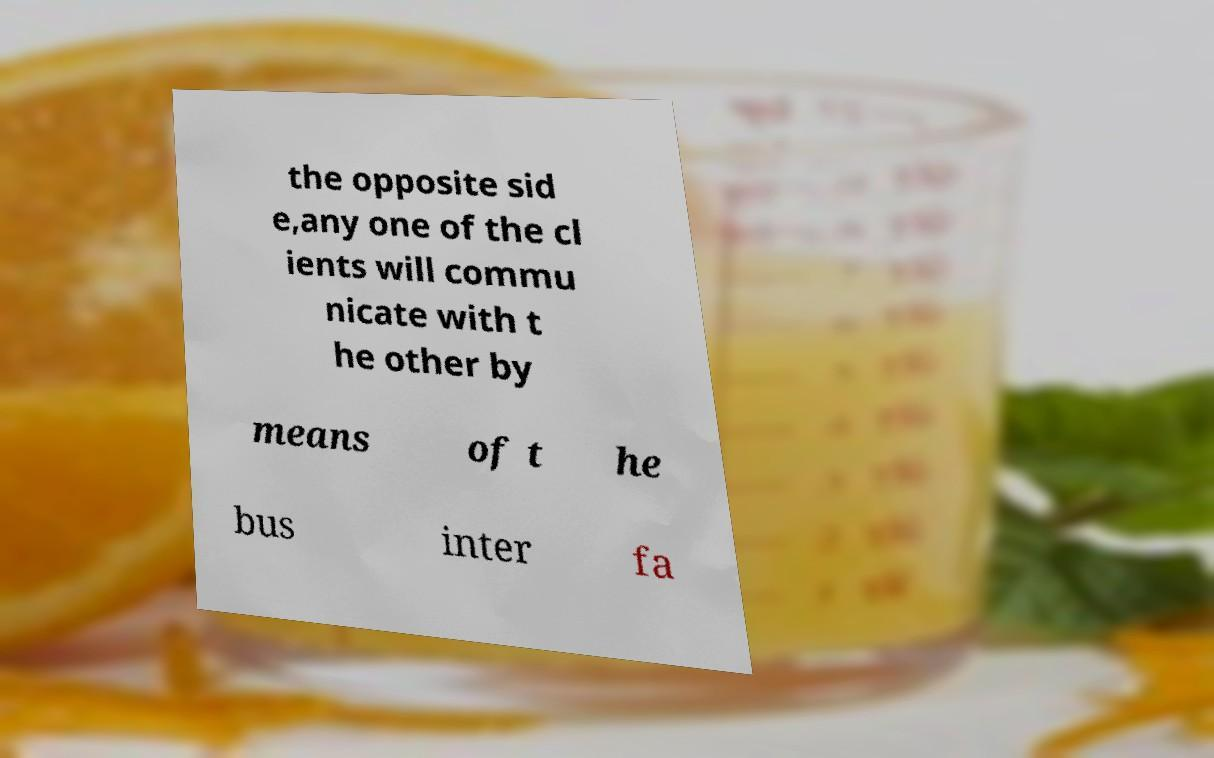Could you assist in decoding the text presented in this image and type it out clearly? the opposite sid e,any one of the cl ients will commu nicate with t he other by means of t he bus inter fa 